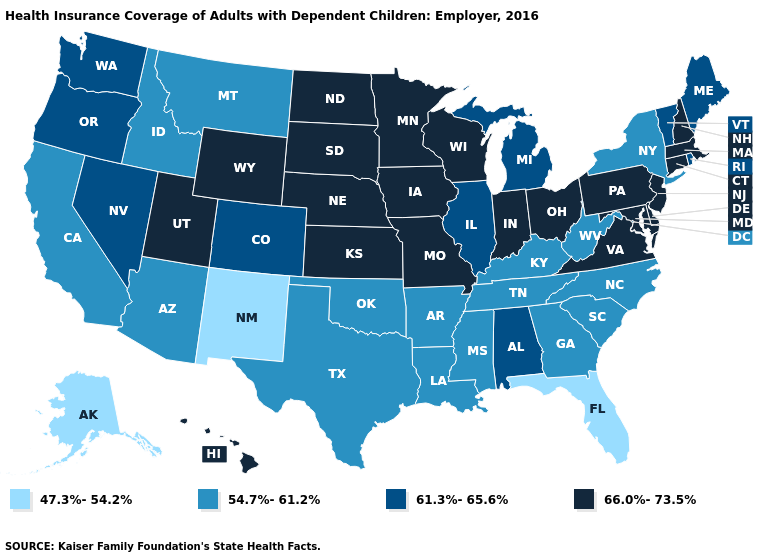Name the states that have a value in the range 47.3%-54.2%?
Keep it brief. Alaska, Florida, New Mexico. Does South Dakota have the lowest value in the MidWest?
Give a very brief answer. No. What is the value of Maine?
Keep it brief. 61.3%-65.6%. Does Mississippi have the same value as Nevada?
Quick response, please. No. What is the value of Kansas?
Concise answer only. 66.0%-73.5%. Is the legend a continuous bar?
Keep it brief. No. Which states have the lowest value in the West?
Keep it brief. Alaska, New Mexico. What is the value of Vermont?
Short answer required. 61.3%-65.6%. What is the highest value in the USA?
Short answer required. 66.0%-73.5%. What is the value of Missouri?
Answer briefly. 66.0%-73.5%. Name the states that have a value in the range 47.3%-54.2%?
Write a very short answer. Alaska, Florida, New Mexico. Name the states that have a value in the range 66.0%-73.5%?
Short answer required. Connecticut, Delaware, Hawaii, Indiana, Iowa, Kansas, Maryland, Massachusetts, Minnesota, Missouri, Nebraska, New Hampshire, New Jersey, North Dakota, Ohio, Pennsylvania, South Dakota, Utah, Virginia, Wisconsin, Wyoming. Does West Virginia have the lowest value in the USA?
Write a very short answer. No. Name the states that have a value in the range 66.0%-73.5%?
Concise answer only. Connecticut, Delaware, Hawaii, Indiana, Iowa, Kansas, Maryland, Massachusetts, Minnesota, Missouri, Nebraska, New Hampshire, New Jersey, North Dakota, Ohio, Pennsylvania, South Dakota, Utah, Virginia, Wisconsin, Wyoming. Does Delaware have the same value as Alabama?
Concise answer only. No. 